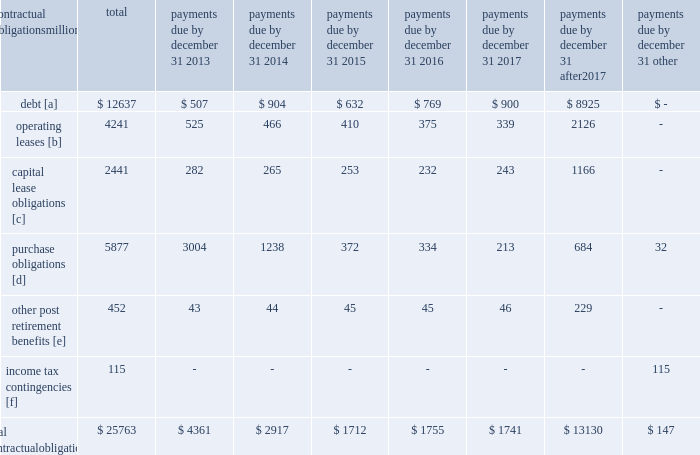Credit rating fall below investment grade , the value of the outstanding undivided interest held by investors would be reduced , and , in certain cases , the investors would have the right to discontinue the facility .
The railroad collected approximately $ 20.1 billion and $ 18.8 billion of receivables during the years ended december 31 , 2012 and 2011 , respectively .
Upri used certain of these proceeds to purchase new receivables under the facility .
The costs of the receivables securitization facility include interest , which will vary based on prevailing commercial paper rates , program fees paid to banks , commercial paper issuing costs , and fees for unused commitment availability .
The costs of the receivables securitization facility are included in interest expense and were $ 3 million , $ 4 million and $ 6 million for 2012 , 2011 and 2010 , respectively .
The investors have no recourse to the railroad 2019s other assets , except for customary warranty and indemnity claims .
Creditors of the railroad do not have recourse to the assets of upri .
In july 2012 , the receivables securitization facility was renewed for an additional 364-day period at comparable terms and conditions .
Subsequent event 2013 on january 2 , 2013 , we transferred an additional $ 300 million in undivided interest to investors under the receivables securitization facility , increasing the value of the outstanding undivided interest held by investors from $ 100 million to $ 400 million .
Contractual obligations and commercial commitments as described in the notes to the consolidated financial statements and as referenced in the tables below , we have contractual obligations and commercial commitments that may affect our financial condition .
Based on our assessment of the underlying provisions and circumstances of our contractual obligations and commercial commitments , including material sources of off-balance sheet and structured finance arrangements , other than the risks that we and other similarly situated companies face with respect to the condition of the capital markets ( as described in item 1a of part ii of this report ) , there is no known trend , demand , commitment , event , or uncertainty that is reasonably likely to occur that would have a material adverse effect on our consolidated results of operations , financial condition , or liquidity .
In addition , our commercial obligations , financings , and commitments are customary transactions that are similar to those of other comparable corporations , particularly within the transportation industry .
The tables identify material obligations and commitments as of december 31 , 2012 : payments due by december 31 , contractual obligations after millions total 2013 2014 2015 2016 2017 2017 other .
[a] excludes capital lease obligations of $ 1848 million and unamortized discount of $ ( 365 ) million .
Includes an interest component of $ 5123 million .
[b] includes leases for locomotives , freight cars , other equipment , and real estate .
[c] represents total obligations , including interest component of $ 593 million .
[d] purchase obligations include locomotive maintenance contracts ; purchase commitments for fuel purchases , locomotives , ties , ballast , and rail ; and agreements to purchase other goods and services .
For amounts where we cannot reasonably estimate the year of settlement , they are reflected in the other column .
[e] includes estimated other post retirement , medical , and life insurance payments , payments made under the unfunded pension plan for the next ten years .
[f] future cash flows for income tax contingencies reflect the recorded liabilities and assets for unrecognized tax benefits , including interest and penalties , as of december 31 , 2012 .
For amounts where the year of settlement is uncertain , they are reflected in the other column. .
Was the 2012 ending balance under the receivables securitization facility sufficient to fund the 2013 payments due for operating leases? 
Computations: (100 > 525)
Answer: no. 